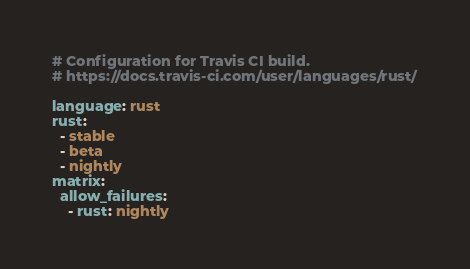<code> <loc_0><loc_0><loc_500><loc_500><_YAML_># Configuration for Travis CI build.
# https://docs.travis-ci.com/user/languages/rust/

language: rust
rust:
  - stable
  - beta
  - nightly
matrix:
  allow_failures:
    - rust: nightly
</code> 